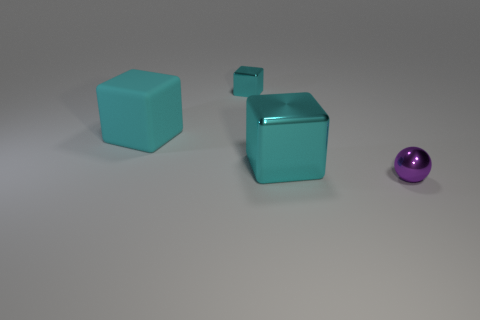Subtract all metal blocks. How many blocks are left? 1 Add 3 small objects. How many objects exist? 7 Subtract all balls. How many objects are left? 3 Add 3 big cyan blocks. How many big cyan blocks are left? 5 Add 2 brown metallic cylinders. How many brown metallic cylinders exist? 2 Subtract 0 blue blocks. How many objects are left? 4 Subtract all metallic blocks. Subtract all yellow shiny blocks. How many objects are left? 2 